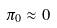Convert formula to latex. <formula><loc_0><loc_0><loc_500><loc_500>\pi _ { 0 } \approx 0</formula> 